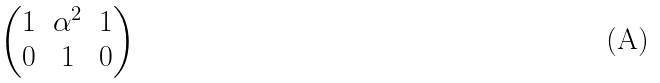Convert formula to latex. <formula><loc_0><loc_0><loc_500><loc_500>\begin{pmatrix} 1 & \alpha ^ { 2 } & 1 \\ 0 & 1 & 0 \end{pmatrix}</formula> 